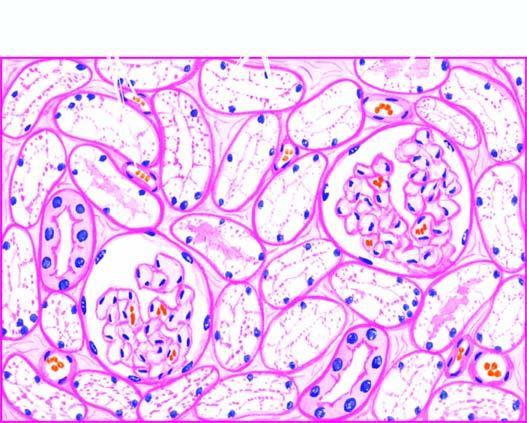re the tubular epithelial cells distended with cytoplasmic vacuoles while the interstitial vasculature is compressed?
Answer the question using a single word or phrase. Yes 